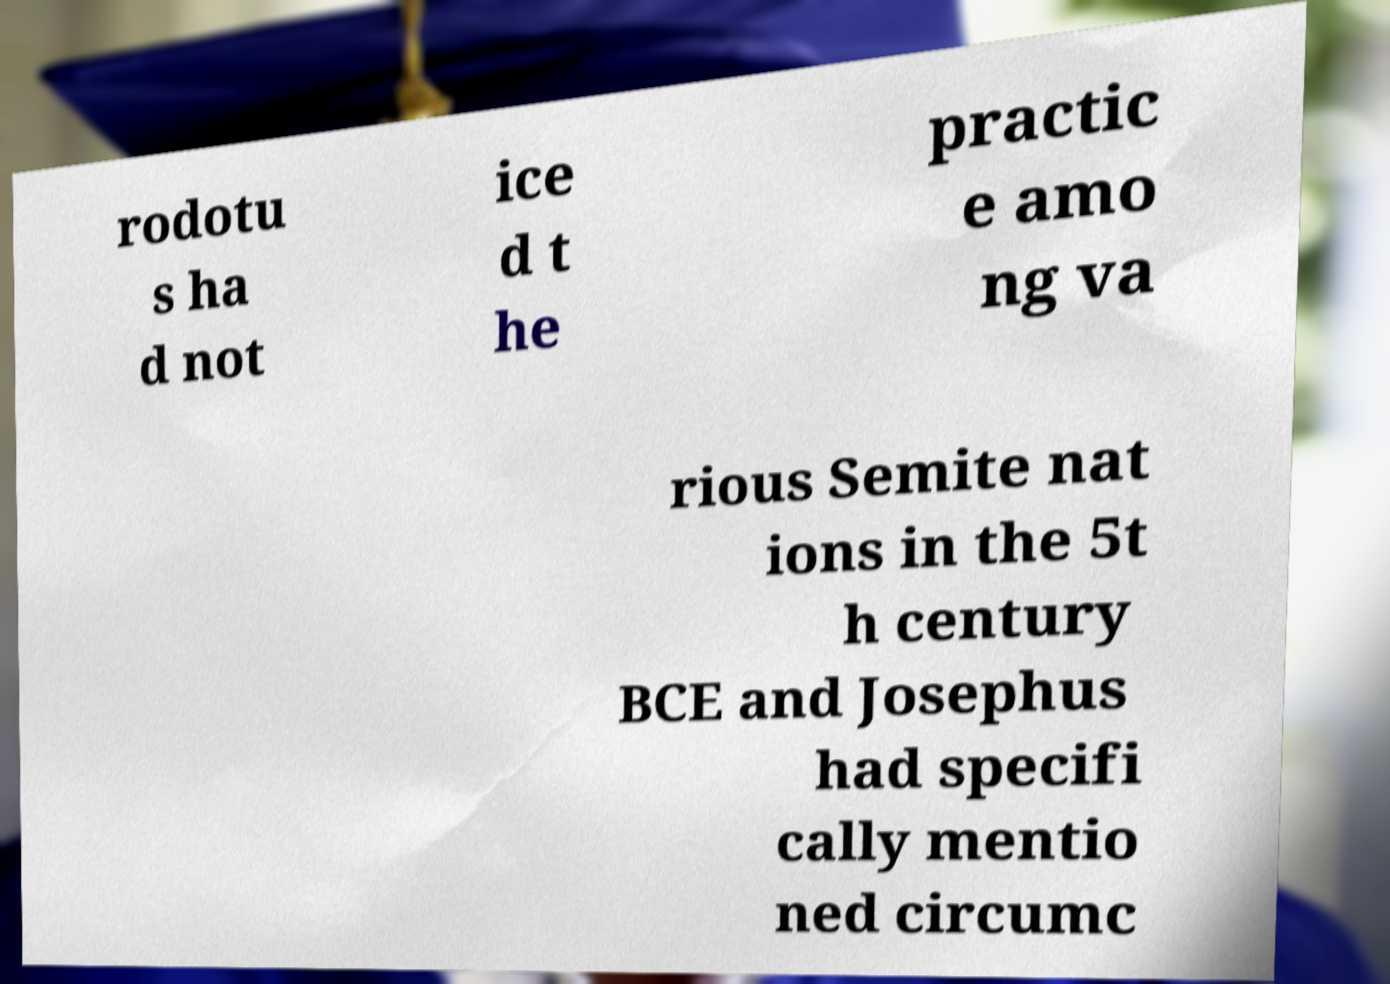Could you extract and type out the text from this image? rodotu s ha d not ice d t he practic e amo ng va rious Semite nat ions in the 5t h century BCE and Josephus had specifi cally mentio ned circumc 